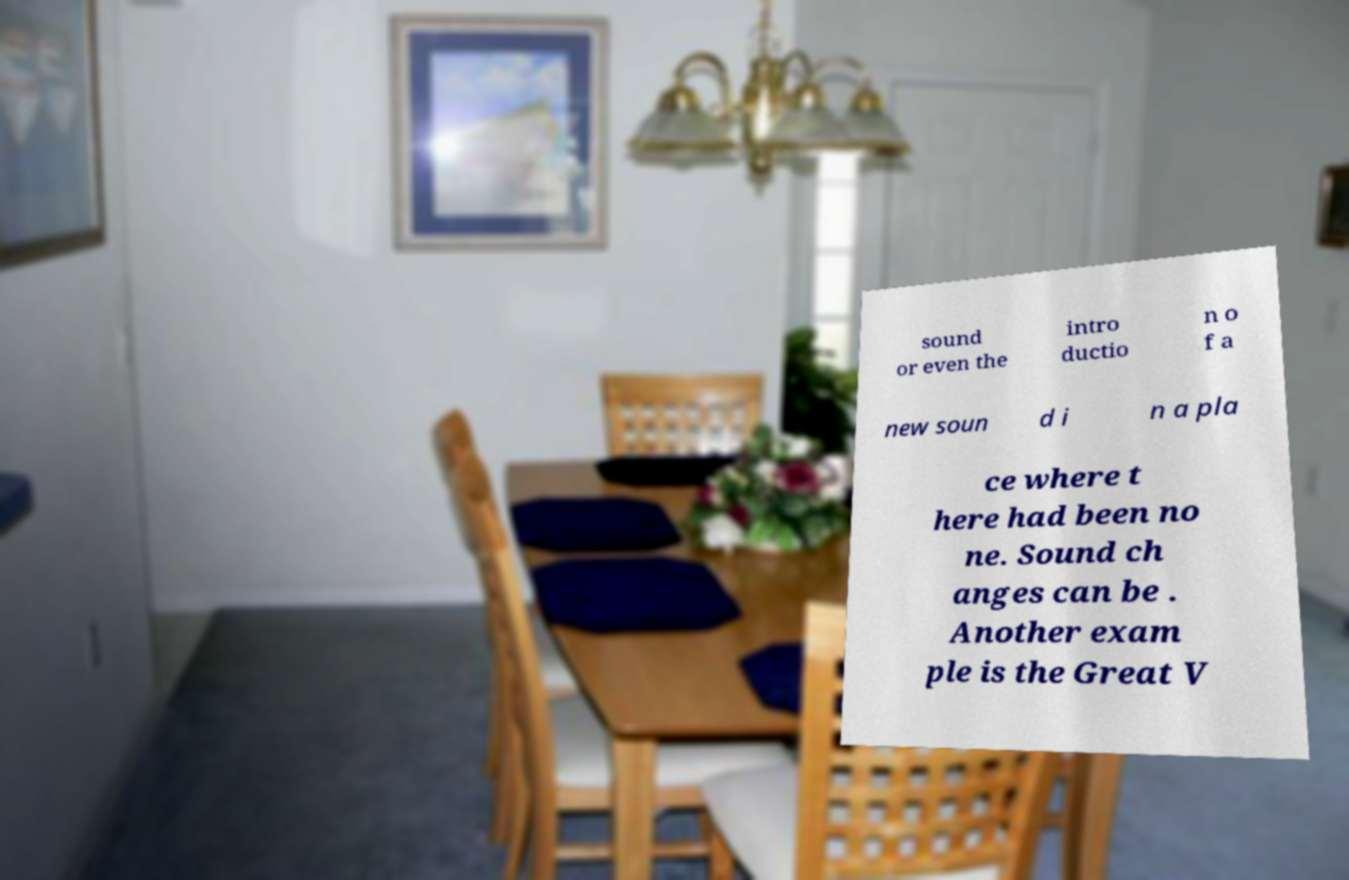Please read and relay the text visible in this image. What does it say? sound or even the intro ductio n o f a new soun d i n a pla ce where t here had been no ne. Sound ch anges can be . Another exam ple is the Great V 